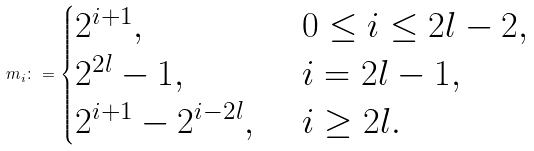Convert formula to latex. <formula><loc_0><loc_0><loc_500><loc_500>m _ { i } \colon = \begin{cases} 2 ^ { i + 1 } , & \ 0 \leq i \leq 2 l - 2 , \\ 2 ^ { 2 l } - 1 , & \ i = 2 l - 1 , \\ 2 ^ { i + 1 } - 2 ^ { i - 2 l } , & \ i \geq 2 l . \end{cases}</formula> 